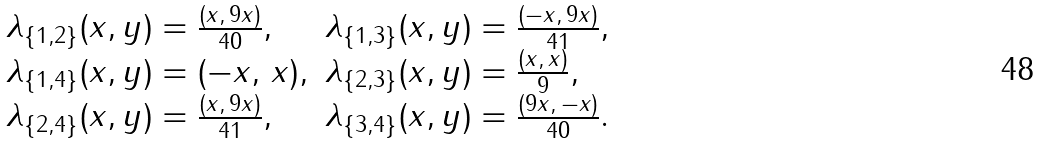Convert formula to latex. <formula><loc_0><loc_0><loc_500><loc_500>\begin{array} { l l } \lambda _ { \{ 1 , 2 \} } ( x , y ) = \frac { ( x , \, 9 x ) } { 4 0 } , & \lambda _ { \{ 1 , 3 \} } ( x , y ) = \frac { ( - x , \, 9 x ) } { 4 1 } , \\ \lambda _ { \{ 1 , 4 \} } ( x , y ) = ( - x , \, x ) , & \lambda _ { \{ 2 , 3 \} } ( x , y ) = \frac { ( x , \, x ) } { 9 } , \\ \lambda _ { \{ 2 , 4 \} } ( x , y ) = \frac { ( x , \, 9 x ) } { 4 1 } , & \lambda _ { \{ 3 , 4 \} } ( x , y ) = \frac { ( 9 x , \, - x ) } { 4 0 } . \end{array}</formula> 